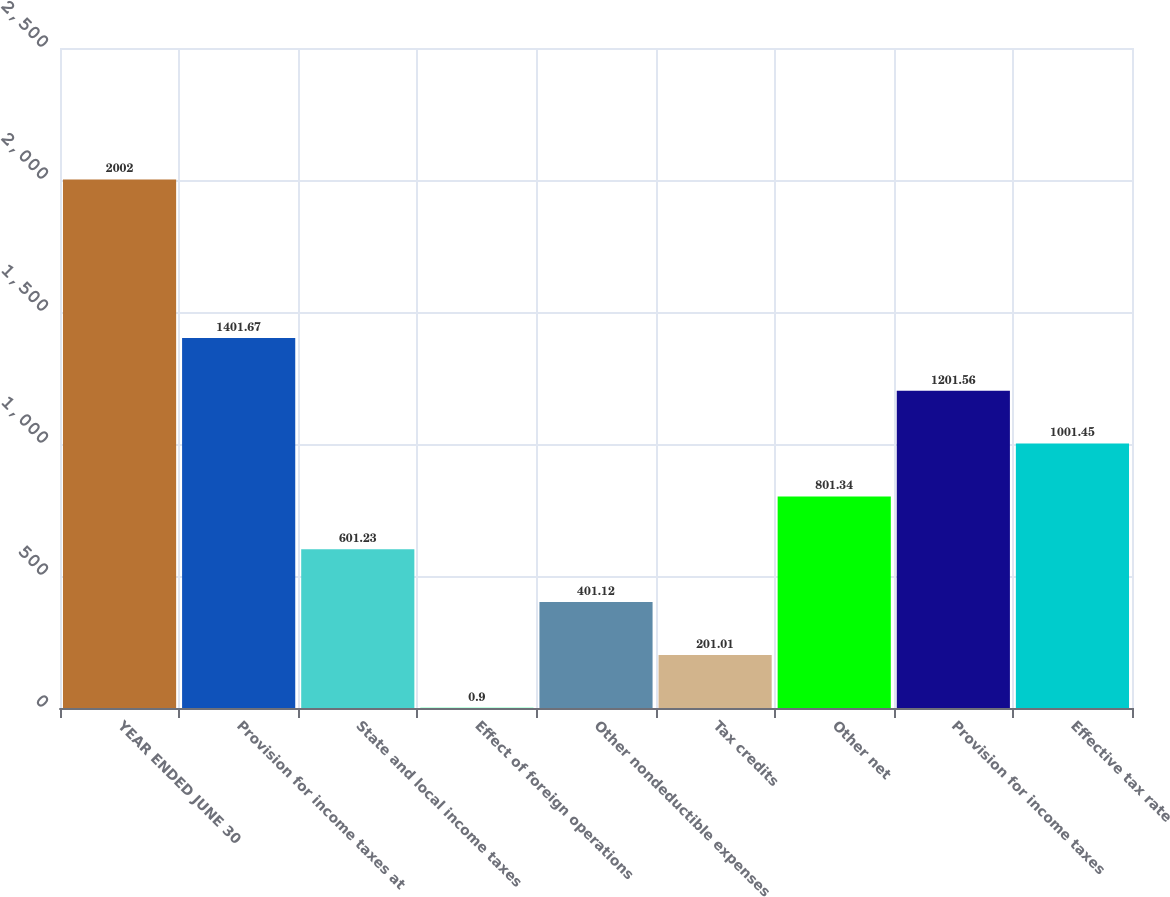<chart> <loc_0><loc_0><loc_500><loc_500><bar_chart><fcel>YEAR ENDED JUNE 30<fcel>Provision for income taxes at<fcel>State and local income taxes<fcel>Effect of foreign operations<fcel>Other nondeductible expenses<fcel>Tax credits<fcel>Other net<fcel>Provision for income taxes<fcel>Effective tax rate<nl><fcel>2002<fcel>1401.67<fcel>601.23<fcel>0.9<fcel>401.12<fcel>201.01<fcel>801.34<fcel>1201.56<fcel>1001.45<nl></chart> 